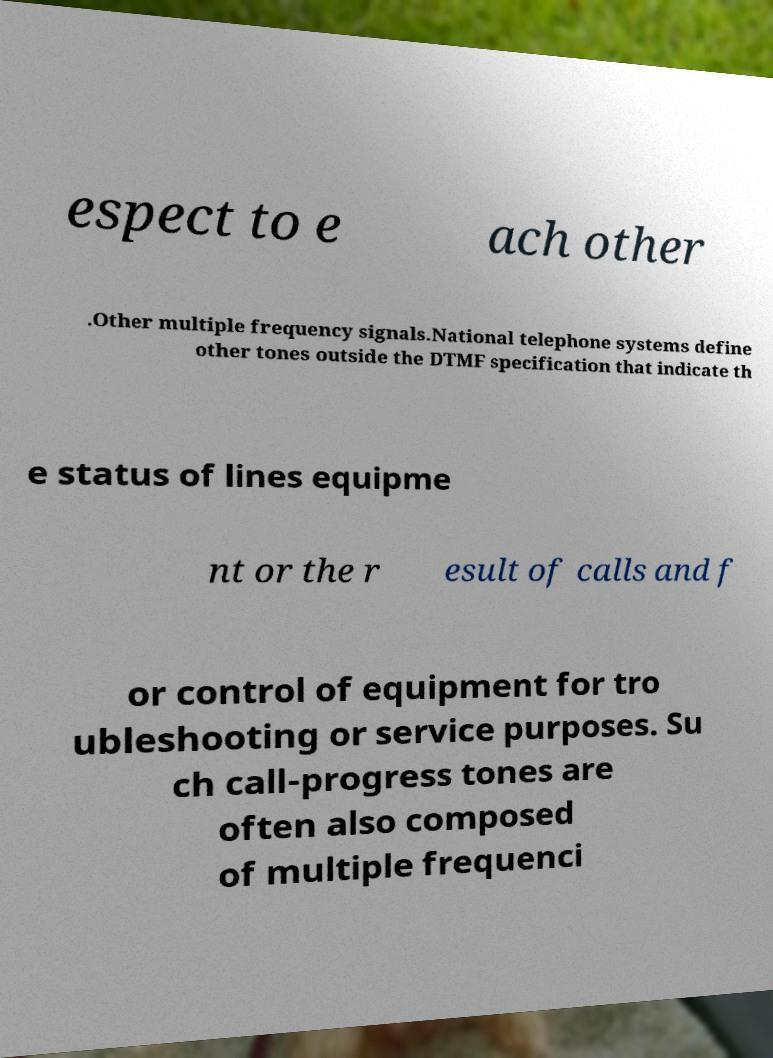For documentation purposes, I need the text within this image transcribed. Could you provide that? espect to e ach other .Other multiple frequency signals.National telephone systems define other tones outside the DTMF specification that indicate th e status of lines equipme nt or the r esult of calls and f or control of equipment for tro ubleshooting or service purposes. Su ch call-progress tones are often also composed of multiple frequenci 